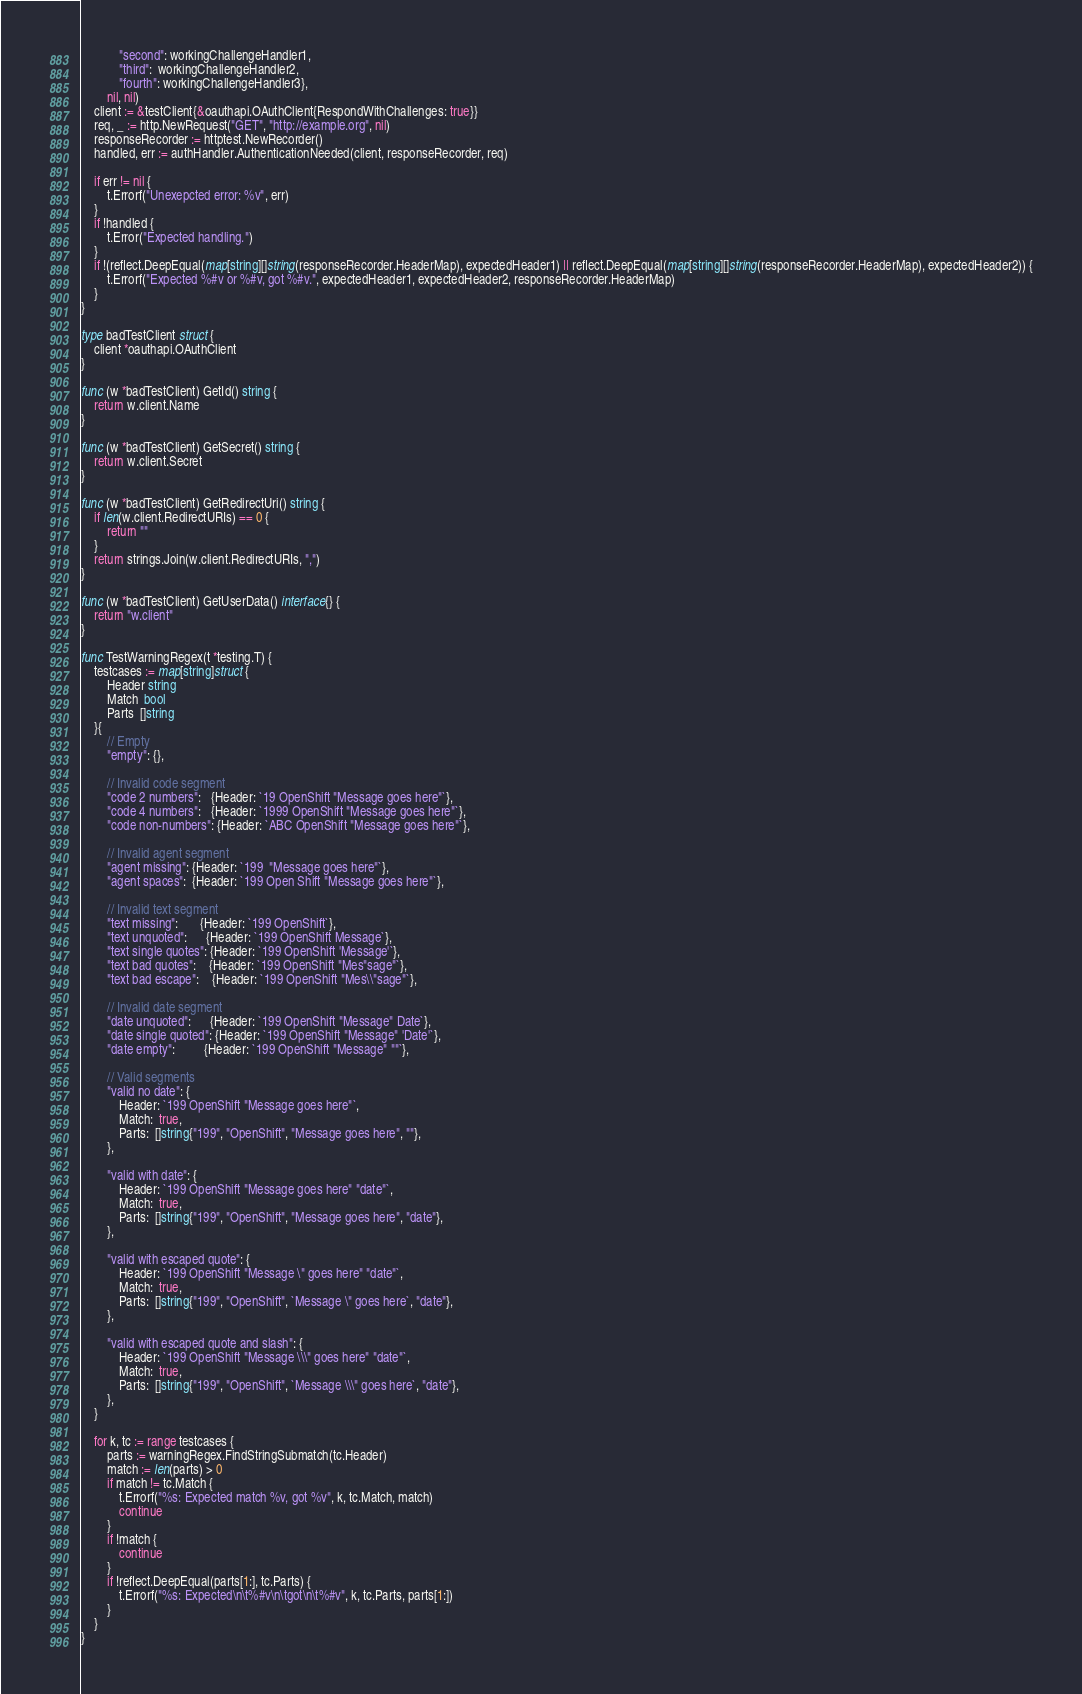Convert code to text. <code><loc_0><loc_0><loc_500><loc_500><_Go_>			"second": workingChallengeHandler1,
			"third":  workingChallengeHandler2,
			"fourth": workingChallengeHandler3},
		nil, nil)
	client := &testClient{&oauthapi.OAuthClient{RespondWithChallenges: true}}
	req, _ := http.NewRequest("GET", "http://example.org", nil)
	responseRecorder := httptest.NewRecorder()
	handled, err := authHandler.AuthenticationNeeded(client, responseRecorder, req)

	if err != nil {
		t.Errorf("Unexepcted error: %v", err)
	}
	if !handled {
		t.Error("Expected handling.")
	}
	if !(reflect.DeepEqual(map[string][]string(responseRecorder.HeaderMap), expectedHeader1) || reflect.DeepEqual(map[string][]string(responseRecorder.HeaderMap), expectedHeader2)) {
		t.Errorf("Expected %#v or %#v, got %#v.", expectedHeader1, expectedHeader2, responseRecorder.HeaderMap)
	}
}

type badTestClient struct {
	client *oauthapi.OAuthClient
}

func (w *badTestClient) GetId() string {
	return w.client.Name
}

func (w *badTestClient) GetSecret() string {
	return w.client.Secret
}

func (w *badTestClient) GetRedirectUri() string {
	if len(w.client.RedirectURIs) == 0 {
		return ""
	}
	return strings.Join(w.client.RedirectURIs, ",")
}

func (w *badTestClient) GetUserData() interface{} {
	return "w.client"
}

func TestWarningRegex(t *testing.T) {
	testcases := map[string]struct {
		Header string
		Match  bool
		Parts  []string
	}{
		// Empty
		"empty": {},

		// Invalid code segment
		"code 2 numbers":   {Header: `19 OpenShift "Message goes here"`},
		"code 4 numbers":   {Header: `1999 OpenShift "Message goes here"`},
		"code non-numbers": {Header: `ABC OpenShift "Message goes here"`},

		// Invalid agent segment
		"agent missing": {Header: `199  "Message goes here"`},
		"agent spaces":  {Header: `199 Open Shift "Message goes here"`},

		// Invalid text segment
		"text missing":       {Header: `199 OpenShift`},
		"text unquoted":      {Header: `199 OpenShift Message`},
		"text single quotes": {Header: `199 OpenShift 'Message'`},
		"text bad quotes":    {Header: `199 OpenShift "Mes"sage"`},
		"text bad escape":    {Header: `199 OpenShift "Mes\\"sage"`},

		// Invalid date segment
		"date unquoted":      {Header: `199 OpenShift "Message" Date`},
		"date single quoted": {Header: `199 OpenShift "Message" 'Date'`},
		"date empty":         {Header: `199 OpenShift "Message" ""`},

		// Valid segments
		"valid no date": {
			Header: `199 OpenShift "Message goes here"`,
			Match:  true,
			Parts:  []string{"199", "OpenShift", "Message goes here", ""},
		},

		"valid with date": {
			Header: `199 OpenShift "Message goes here" "date"`,
			Match:  true,
			Parts:  []string{"199", "OpenShift", "Message goes here", "date"},
		},

		"valid with escaped quote": {
			Header: `199 OpenShift "Message \" goes here" "date"`,
			Match:  true,
			Parts:  []string{"199", "OpenShift", `Message \" goes here`, "date"},
		},

		"valid with escaped quote and slash": {
			Header: `199 OpenShift "Message \\\" goes here" "date"`,
			Match:  true,
			Parts:  []string{"199", "OpenShift", `Message \\\" goes here`, "date"},
		},
	}

	for k, tc := range testcases {
		parts := warningRegex.FindStringSubmatch(tc.Header)
		match := len(parts) > 0
		if match != tc.Match {
			t.Errorf("%s: Expected match %v, got %v", k, tc.Match, match)
			continue
		}
		if !match {
			continue
		}
		if !reflect.DeepEqual(parts[1:], tc.Parts) {
			t.Errorf("%s: Expected\n\t%#v\n\tgot\n\t%#v", k, tc.Parts, parts[1:])
		}
	}
}
</code> 